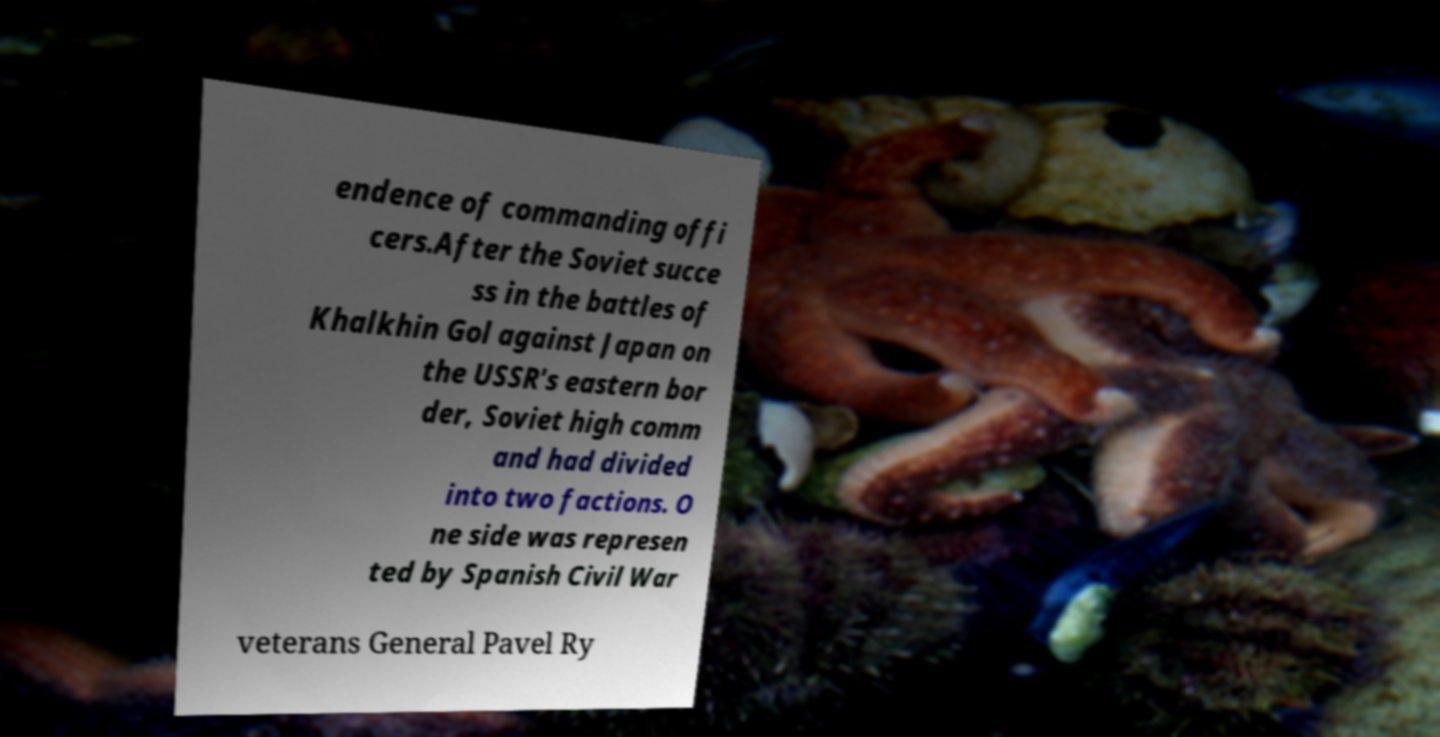Please identify and transcribe the text found in this image. endence of commanding offi cers.After the Soviet succe ss in the battles of Khalkhin Gol against Japan on the USSR's eastern bor der, Soviet high comm and had divided into two factions. O ne side was represen ted by Spanish Civil War veterans General Pavel Ry 